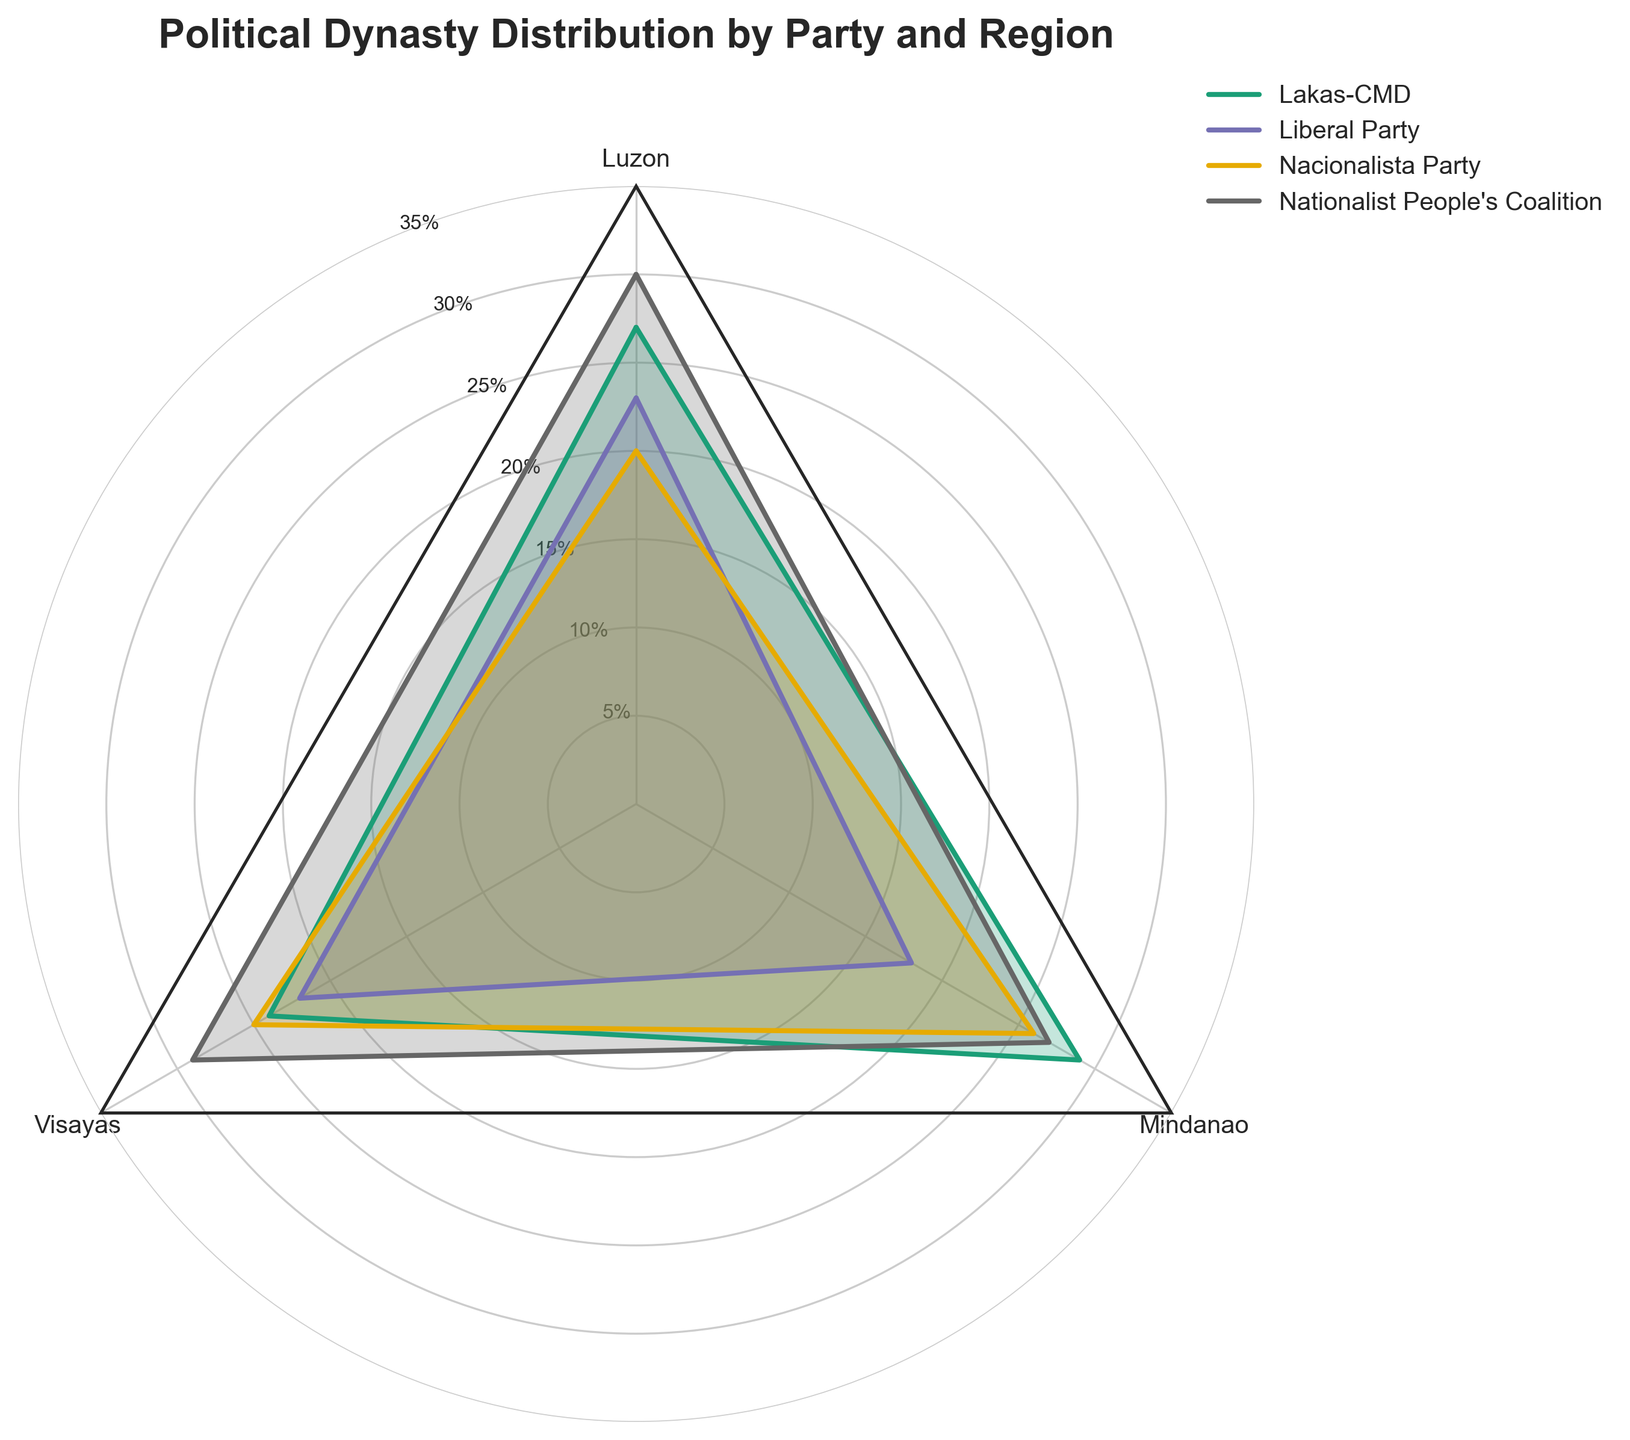Which region has the highest percentage of political dynasties represented by Lakas-CMD? The region with the peak percentage for Lakas-CMD on the radar chart shows the numerical comparison of Luzon, Visayas, and Mindanao. Mindanao leads with 29%.
Answer: Mindanao Which party has the lowest percentage of political dynasties in Mindanao? The radar chart displays three parties in Mindanao: Lakas-CMD (29%), Liberal Party (18%), Nacionalista Party (26%), and Nationalist People's Coalition (27%). The Liberal Party has the lowest at 18%.
Answer: Liberal Party What is the total percentage of political dynasties represented by Nacionalista Party across all regions? Sum up the percentages for Nacionalista Party in Luzon (20%), Visayas (25%), and Mindanao (26%). 20 + 25 + 26 = 71%.
Answer: 71% Compare the percentage of political dynasties for Nationalist People's Coalition between Luzon and Visayas. Which is higher? Check the radar chart for the Nationalist People's Coalition in Luzon (30%) and Visayas (29%). The percentage in Luzon is higher.
Answer: Luzon Which political party has a more balanced distribution of political dynasties across regions? Examining the radar chart, the Liberal Party shows similar percentages in Luzon (23%), Visayas (22%), and Mindanao (18%), indicating a more balanced distribution.
Answer: Liberal Party What is the average percentage of political dynasties for Lakas-CMD across all regions? Calculate the average percentage by summing the values for Luzon (27%), Visayas (24%), and Mindanao (29%), and then divide by 3. (27 + 24 + 29) / 3 = 26.67%.
Answer: 26.67% Which party has the highest single regional percentage of political dynasties? Identify the highest percentage on the radar chart, with Nationalist People's Coalition in Luzon at 30%.
Answer: Nationalist People's Coalition How does the percentage distribution of political dynasties for the Liberal Party in Luzon compare to the Nacionalista Party in the same region? Comparing the percentages on the radar chart, the Liberal Party has 23% in Luzon, while Nacionalista Party has 20%.
Answer: Liberal Party What is the difference in the percentage of political dynasties between Lakas-CMD and the Liberal Party in Mindanao? Subtract the Liberal Party's percentage in Mindanao (18%) from Lakas-CMD's (29%). 29 - 18 = 11%.
Answer: 11% 